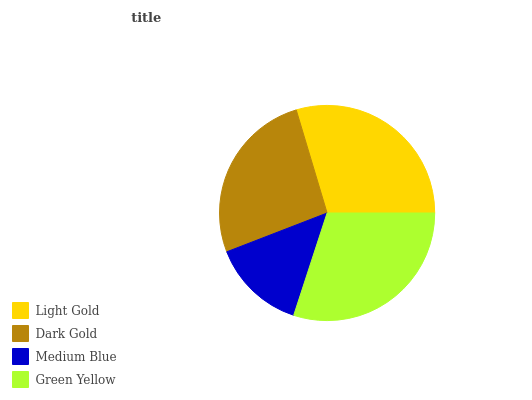Is Medium Blue the minimum?
Answer yes or no. Yes. Is Green Yellow the maximum?
Answer yes or no. Yes. Is Dark Gold the minimum?
Answer yes or no. No. Is Dark Gold the maximum?
Answer yes or no. No. Is Light Gold greater than Dark Gold?
Answer yes or no. Yes. Is Dark Gold less than Light Gold?
Answer yes or no. Yes. Is Dark Gold greater than Light Gold?
Answer yes or no. No. Is Light Gold less than Dark Gold?
Answer yes or no. No. Is Light Gold the high median?
Answer yes or no. Yes. Is Dark Gold the low median?
Answer yes or no. Yes. Is Green Yellow the high median?
Answer yes or no. No. Is Light Gold the low median?
Answer yes or no. No. 